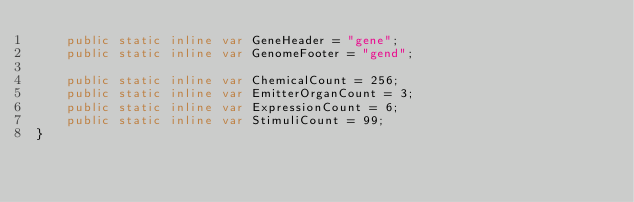Convert code to text. <code><loc_0><loc_0><loc_500><loc_500><_Haxe_>    public static inline var GeneHeader = "gene";
    public static inline var GenomeFooter = "gend";

    public static inline var ChemicalCount = 256;
    public static inline var EmitterOrganCount = 3;
    public static inline var ExpressionCount = 6;
    public static inline var StimuliCount = 99;
}</code> 